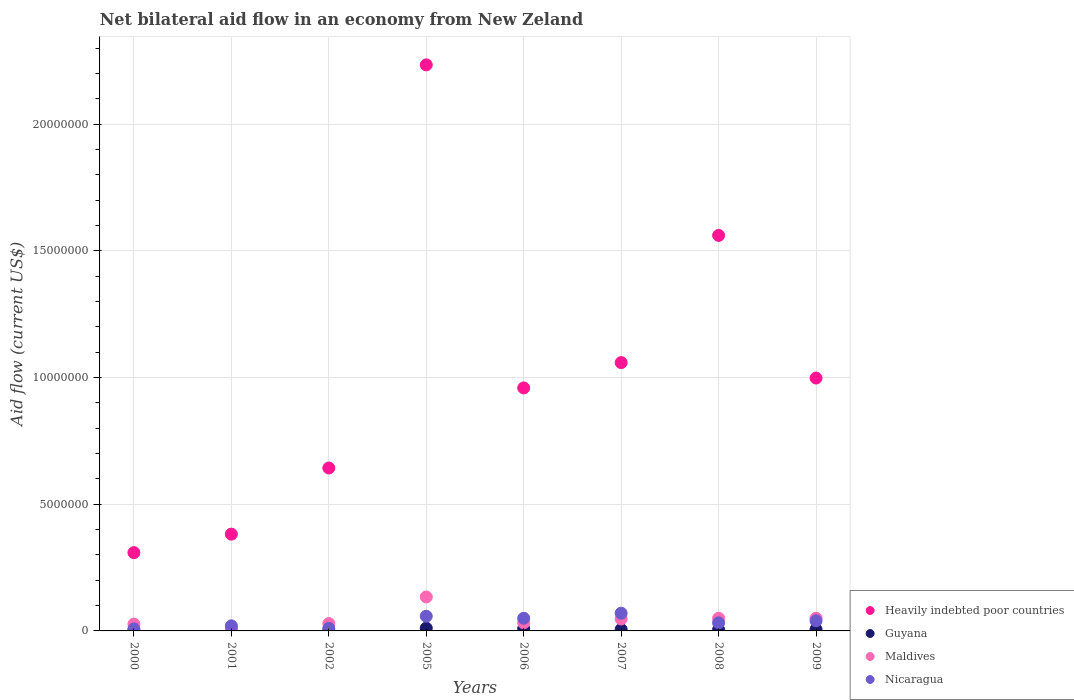Is the number of dotlines equal to the number of legend labels?
Your response must be concise. Yes. What is the net bilateral aid flow in Heavily indebted poor countries in 2009?
Offer a very short reply. 9.98e+06. Across all years, what is the maximum net bilateral aid flow in Guyana?
Give a very brief answer. 1.10e+05. Across all years, what is the minimum net bilateral aid flow in Maldives?
Your answer should be very brief. 1.20e+05. What is the total net bilateral aid flow in Nicaragua in the graph?
Your answer should be very brief. 2.88e+06. What is the difference between the net bilateral aid flow in Heavily indebted poor countries in 2001 and that in 2009?
Provide a succinct answer. -6.16e+06. What is the difference between the net bilateral aid flow in Guyana in 2006 and the net bilateral aid flow in Maldives in 2009?
Give a very brief answer. -4.10e+05. What is the average net bilateral aid flow in Heavily indebted poor countries per year?
Offer a terse response. 1.02e+07. In the year 2000, what is the difference between the net bilateral aid flow in Guyana and net bilateral aid flow in Maldives?
Offer a very short reply. -2.60e+05. In how many years, is the net bilateral aid flow in Guyana greater than 18000000 US$?
Offer a very short reply. 0. Is the difference between the net bilateral aid flow in Guyana in 2002 and 2005 greater than the difference between the net bilateral aid flow in Maldives in 2002 and 2005?
Ensure brevity in your answer.  Yes. What is the difference between the highest and the second highest net bilateral aid flow in Nicaragua?
Offer a very short reply. 1.20e+05. What is the difference between the highest and the lowest net bilateral aid flow in Maldives?
Offer a terse response. 1.22e+06. In how many years, is the net bilateral aid flow in Maldives greater than the average net bilateral aid flow in Maldives taken over all years?
Provide a short and direct response. 3. Is it the case that in every year, the sum of the net bilateral aid flow in Nicaragua and net bilateral aid flow in Guyana  is greater than the net bilateral aid flow in Maldives?
Your answer should be compact. No. Is the net bilateral aid flow in Heavily indebted poor countries strictly greater than the net bilateral aid flow in Guyana over the years?
Your answer should be compact. Yes. Is the net bilateral aid flow in Heavily indebted poor countries strictly less than the net bilateral aid flow in Nicaragua over the years?
Offer a terse response. No. How many dotlines are there?
Your answer should be very brief. 4. Are the values on the major ticks of Y-axis written in scientific E-notation?
Offer a terse response. No. Does the graph contain any zero values?
Offer a very short reply. No. Does the graph contain grids?
Keep it short and to the point. Yes. What is the title of the graph?
Provide a succinct answer. Net bilateral aid flow in an economy from New Zeland. What is the label or title of the X-axis?
Give a very brief answer. Years. What is the label or title of the Y-axis?
Provide a succinct answer. Aid flow (current US$). What is the Aid flow (current US$) in Heavily indebted poor countries in 2000?
Your response must be concise. 3.09e+06. What is the Aid flow (current US$) of Guyana in 2000?
Give a very brief answer. 10000. What is the Aid flow (current US$) of Heavily indebted poor countries in 2001?
Offer a very short reply. 3.82e+06. What is the Aid flow (current US$) of Guyana in 2001?
Ensure brevity in your answer.  10000. What is the Aid flow (current US$) of Maldives in 2001?
Your response must be concise. 1.20e+05. What is the Aid flow (current US$) of Heavily indebted poor countries in 2002?
Keep it short and to the point. 6.43e+06. What is the Aid flow (current US$) of Guyana in 2002?
Give a very brief answer. 10000. What is the Aid flow (current US$) of Maldives in 2002?
Your answer should be compact. 2.90e+05. What is the Aid flow (current US$) in Heavily indebted poor countries in 2005?
Provide a short and direct response. 2.23e+07. What is the Aid flow (current US$) of Maldives in 2005?
Provide a short and direct response. 1.34e+06. What is the Aid flow (current US$) of Nicaragua in 2005?
Give a very brief answer. 5.80e+05. What is the Aid flow (current US$) in Heavily indebted poor countries in 2006?
Ensure brevity in your answer.  9.59e+06. What is the Aid flow (current US$) of Maldives in 2006?
Provide a short and direct response. 3.20e+05. What is the Aid flow (current US$) in Heavily indebted poor countries in 2007?
Provide a short and direct response. 1.06e+07. What is the Aid flow (current US$) of Guyana in 2007?
Make the answer very short. 6.00e+04. What is the Aid flow (current US$) of Heavily indebted poor countries in 2008?
Your answer should be compact. 1.56e+07. What is the Aid flow (current US$) of Nicaragua in 2008?
Offer a very short reply. 3.20e+05. What is the Aid flow (current US$) in Heavily indebted poor countries in 2009?
Keep it short and to the point. 9.98e+06. What is the Aid flow (current US$) of Guyana in 2009?
Your response must be concise. 6.00e+04. What is the Aid flow (current US$) of Maldives in 2009?
Give a very brief answer. 5.00e+05. What is the Aid flow (current US$) in Nicaragua in 2009?
Keep it short and to the point. 4.00e+05. Across all years, what is the maximum Aid flow (current US$) in Heavily indebted poor countries?
Offer a terse response. 2.23e+07. Across all years, what is the maximum Aid flow (current US$) of Guyana?
Provide a succinct answer. 1.10e+05. Across all years, what is the maximum Aid flow (current US$) of Maldives?
Offer a terse response. 1.34e+06. Across all years, what is the minimum Aid flow (current US$) of Heavily indebted poor countries?
Offer a terse response. 3.09e+06. Across all years, what is the minimum Aid flow (current US$) in Nicaragua?
Your answer should be very brief. 8.00e+04. What is the total Aid flow (current US$) of Heavily indebted poor countries in the graph?
Your response must be concise. 8.14e+07. What is the total Aid flow (current US$) in Guyana in the graph?
Offer a very short reply. 4.00e+05. What is the total Aid flow (current US$) in Maldives in the graph?
Your response must be concise. 3.81e+06. What is the total Aid flow (current US$) of Nicaragua in the graph?
Make the answer very short. 2.88e+06. What is the difference between the Aid flow (current US$) of Heavily indebted poor countries in 2000 and that in 2001?
Provide a short and direct response. -7.30e+05. What is the difference between the Aid flow (current US$) in Guyana in 2000 and that in 2001?
Ensure brevity in your answer.  0. What is the difference between the Aid flow (current US$) in Maldives in 2000 and that in 2001?
Ensure brevity in your answer.  1.50e+05. What is the difference between the Aid flow (current US$) of Nicaragua in 2000 and that in 2001?
Provide a succinct answer. -1.20e+05. What is the difference between the Aid flow (current US$) in Heavily indebted poor countries in 2000 and that in 2002?
Ensure brevity in your answer.  -3.34e+06. What is the difference between the Aid flow (current US$) of Nicaragua in 2000 and that in 2002?
Provide a short and direct response. -2.00e+04. What is the difference between the Aid flow (current US$) in Heavily indebted poor countries in 2000 and that in 2005?
Keep it short and to the point. -1.92e+07. What is the difference between the Aid flow (current US$) in Maldives in 2000 and that in 2005?
Offer a terse response. -1.07e+06. What is the difference between the Aid flow (current US$) in Nicaragua in 2000 and that in 2005?
Make the answer very short. -5.00e+05. What is the difference between the Aid flow (current US$) of Heavily indebted poor countries in 2000 and that in 2006?
Provide a succinct answer. -6.50e+06. What is the difference between the Aid flow (current US$) of Maldives in 2000 and that in 2006?
Your answer should be compact. -5.00e+04. What is the difference between the Aid flow (current US$) in Nicaragua in 2000 and that in 2006?
Provide a short and direct response. -4.20e+05. What is the difference between the Aid flow (current US$) of Heavily indebted poor countries in 2000 and that in 2007?
Keep it short and to the point. -7.50e+06. What is the difference between the Aid flow (current US$) in Maldives in 2000 and that in 2007?
Keep it short and to the point. -2.00e+05. What is the difference between the Aid flow (current US$) of Nicaragua in 2000 and that in 2007?
Your answer should be very brief. -6.20e+05. What is the difference between the Aid flow (current US$) of Heavily indebted poor countries in 2000 and that in 2008?
Ensure brevity in your answer.  -1.25e+07. What is the difference between the Aid flow (current US$) of Guyana in 2000 and that in 2008?
Provide a succinct answer. -4.00e+04. What is the difference between the Aid flow (current US$) of Heavily indebted poor countries in 2000 and that in 2009?
Offer a terse response. -6.89e+06. What is the difference between the Aid flow (current US$) of Guyana in 2000 and that in 2009?
Offer a terse response. -5.00e+04. What is the difference between the Aid flow (current US$) of Maldives in 2000 and that in 2009?
Ensure brevity in your answer.  -2.30e+05. What is the difference between the Aid flow (current US$) of Nicaragua in 2000 and that in 2009?
Provide a short and direct response. -3.20e+05. What is the difference between the Aid flow (current US$) of Heavily indebted poor countries in 2001 and that in 2002?
Provide a short and direct response. -2.61e+06. What is the difference between the Aid flow (current US$) of Heavily indebted poor countries in 2001 and that in 2005?
Offer a terse response. -1.85e+07. What is the difference between the Aid flow (current US$) in Guyana in 2001 and that in 2005?
Ensure brevity in your answer.  -1.00e+05. What is the difference between the Aid flow (current US$) of Maldives in 2001 and that in 2005?
Your response must be concise. -1.22e+06. What is the difference between the Aid flow (current US$) of Nicaragua in 2001 and that in 2005?
Give a very brief answer. -3.80e+05. What is the difference between the Aid flow (current US$) of Heavily indebted poor countries in 2001 and that in 2006?
Your response must be concise. -5.77e+06. What is the difference between the Aid flow (current US$) in Nicaragua in 2001 and that in 2006?
Make the answer very short. -3.00e+05. What is the difference between the Aid flow (current US$) of Heavily indebted poor countries in 2001 and that in 2007?
Your response must be concise. -6.77e+06. What is the difference between the Aid flow (current US$) in Maldives in 2001 and that in 2007?
Offer a terse response. -3.50e+05. What is the difference between the Aid flow (current US$) of Nicaragua in 2001 and that in 2007?
Ensure brevity in your answer.  -5.00e+05. What is the difference between the Aid flow (current US$) of Heavily indebted poor countries in 2001 and that in 2008?
Offer a very short reply. -1.18e+07. What is the difference between the Aid flow (current US$) in Maldives in 2001 and that in 2008?
Offer a terse response. -3.80e+05. What is the difference between the Aid flow (current US$) in Heavily indebted poor countries in 2001 and that in 2009?
Give a very brief answer. -6.16e+06. What is the difference between the Aid flow (current US$) of Guyana in 2001 and that in 2009?
Make the answer very short. -5.00e+04. What is the difference between the Aid flow (current US$) of Maldives in 2001 and that in 2009?
Ensure brevity in your answer.  -3.80e+05. What is the difference between the Aid flow (current US$) in Heavily indebted poor countries in 2002 and that in 2005?
Provide a succinct answer. -1.59e+07. What is the difference between the Aid flow (current US$) in Maldives in 2002 and that in 2005?
Give a very brief answer. -1.05e+06. What is the difference between the Aid flow (current US$) in Nicaragua in 2002 and that in 2005?
Your answer should be compact. -4.80e+05. What is the difference between the Aid flow (current US$) of Heavily indebted poor countries in 2002 and that in 2006?
Your answer should be very brief. -3.16e+06. What is the difference between the Aid flow (current US$) in Maldives in 2002 and that in 2006?
Make the answer very short. -3.00e+04. What is the difference between the Aid flow (current US$) of Nicaragua in 2002 and that in 2006?
Provide a succinct answer. -4.00e+05. What is the difference between the Aid flow (current US$) of Heavily indebted poor countries in 2002 and that in 2007?
Your answer should be very brief. -4.16e+06. What is the difference between the Aid flow (current US$) in Guyana in 2002 and that in 2007?
Provide a succinct answer. -5.00e+04. What is the difference between the Aid flow (current US$) of Nicaragua in 2002 and that in 2007?
Provide a short and direct response. -6.00e+05. What is the difference between the Aid flow (current US$) of Heavily indebted poor countries in 2002 and that in 2008?
Ensure brevity in your answer.  -9.18e+06. What is the difference between the Aid flow (current US$) in Maldives in 2002 and that in 2008?
Make the answer very short. -2.10e+05. What is the difference between the Aid flow (current US$) of Nicaragua in 2002 and that in 2008?
Offer a terse response. -2.20e+05. What is the difference between the Aid flow (current US$) of Heavily indebted poor countries in 2002 and that in 2009?
Offer a terse response. -3.55e+06. What is the difference between the Aid flow (current US$) in Guyana in 2002 and that in 2009?
Your answer should be compact. -5.00e+04. What is the difference between the Aid flow (current US$) in Maldives in 2002 and that in 2009?
Offer a very short reply. -2.10e+05. What is the difference between the Aid flow (current US$) of Nicaragua in 2002 and that in 2009?
Offer a terse response. -3.00e+05. What is the difference between the Aid flow (current US$) in Heavily indebted poor countries in 2005 and that in 2006?
Ensure brevity in your answer.  1.28e+07. What is the difference between the Aid flow (current US$) of Maldives in 2005 and that in 2006?
Your answer should be compact. 1.02e+06. What is the difference between the Aid flow (current US$) of Nicaragua in 2005 and that in 2006?
Provide a short and direct response. 8.00e+04. What is the difference between the Aid flow (current US$) in Heavily indebted poor countries in 2005 and that in 2007?
Ensure brevity in your answer.  1.18e+07. What is the difference between the Aid flow (current US$) of Maldives in 2005 and that in 2007?
Keep it short and to the point. 8.70e+05. What is the difference between the Aid flow (current US$) in Nicaragua in 2005 and that in 2007?
Make the answer very short. -1.20e+05. What is the difference between the Aid flow (current US$) of Heavily indebted poor countries in 2005 and that in 2008?
Your answer should be compact. 6.73e+06. What is the difference between the Aid flow (current US$) in Guyana in 2005 and that in 2008?
Offer a very short reply. 6.00e+04. What is the difference between the Aid flow (current US$) of Maldives in 2005 and that in 2008?
Your response must be concise. 8.40e+05. What is the difference between the Aid flow (current US$) in Heavily indebted poor countries in 2005 and that in 2009?
Provide a short and direct response. 1.24e+07. What is the difference between the Aid flow (current US$) in Maldives in 2005 and that in 2009?
Make the answer very short. 8.40e+05. What is the difference between the Aid flow (current US$) of Nicaragua in 2005 and that in 2009?
Offer a very short reply. 1.80e+05. What is the difference between the Aid flow (current US$) of Maldives in 2006 and that in 2007?
Your response must be concise. -1.50e+05. What is the difference between the Aid flow (current US$) in Nicaragua in 2006 and that in 2007?
Your answer should be compact. -2.00e+05. What is the difference between the Aid flow (current US$) in Heavily indebted poor countries in 2006 and that in 2008?
Your answer should be compact. -6.02e+06. What is the difference between the Aid flow (current US$) in Guyana in 2006 and that in 2008?
Your response must be concise. 4.00e+04. What is the difference between the Aid flow (current US$) of Heavily indebted poor countries in 2006 and that in 2009?
Provide a succinct answer. -3.90e+05. What is the difference between the Aid flow (current US$) in Guyana in 2006 and that in 2009?
Ensure brevity in your answer.  3.00e+04. What is the difference between the Aid flow (current US$) of Heavily indebted poor countries in 2007 and that in 2008?
Keep it short and to the point. -5.02e+06. What is the difference between the Aid flow (current US$) in Maldives in 2007 and that in 2008?
Your response must be concise. -3.00e+04. What is the difference between the Aid flow (current US$) in Nicaragua in 2007 and that in 2008?
Offer a very short reply. 3.80e+05. What is the difference between the Aid flow (current US$) in Heavily indebted poor countries in 2007 and that in 2009?
Your answer should be compact. 6.10e+05. What is the difference between the Aid flow (current US$) in Guyana in 2007 and that in 2009?
Ensure brevity in your answer.  0. What is the difference between the Aid flow (current US$) of Maldives in 2007 and that in 2009?
Your response must be concise. -3.00e+04. What is the difference between the Aid flow (current US$) in Heavily indebted poor countries in 2008 and that in 2009?
Make the answer very short. 5.63e+06. What is the difference between the Aid flow (current US$) in Guyana in 2008 and that in 2009?
Provide a short and direct response. -10000. What is the difference between the Aid flow (current US$) in Maldives in 2008 and that in 2009?
Offer a terse response. 0. What is the difference between the Aid flow (current US$) in Heavily indebted poor countries in 2000 and the Aid flow (current US$) in Guyana in 2001?
Make the answer very short. 3.08e+06. What is the difference between the Aid flow (current US$) in Heavily indebted poor countries in 2000 and the Aid flow (current US$) in Maldives in 2001?
Offer a terse response. 2.97e+06. What is the difference between the Aid flow (current US$) of Heavily indebted poor countries in 2000 and the Aid flow (current US$) of Nicaragua in 2001?
Provide a short and direct response. 2.89e+06. What is the difference between the Aid flow (current US$) of Guyana in 2000 and the Aid flow (current US$) of Maldives in 2001?
Your answer should be compact. -1.10e+05. What is the difference between the Aid flow (current US$) in Maldives in 2000 and the Aid flow (current US$) in Nicaragua in 2001?
Your answer should be compact. 7.00e+04. What is the difference between the Aid flow (current US$) of Heavily indebted poor countries in 2000 and the Aid flow (current US$) of Guyana in 2002?
Offer a terse response. 3.08e+06. What is the difference between the Aid flow (current US$) of Heavily indebted poor countries in 2000 and the Aid flow (current US$) of Maldives in 2002?
Your response must be concise. 2.80e+06. What is the difference between the Aid flow (current US$) in Heavily indebted poor countries in 2000 and the Aid flow (current US$) in Nicaragua in 2002?
Keep it short and to the point. 2.99e+06. What is the difference between the Aid flow (current US$) in Guyana in 2000 and the Aid flow (current US$) in Maldives in 2002?
Your answer should be very brief. -2.80e+05. What is the difference between the Aid flow (current US$) in Guyana in 2000 and the Aid flow (current US$) in Nicaragua in 2002?
Your answer should be compact. -9.00e+04. What is the difference between the Aid flow (current US$) of Maldives in 2000 and the Aid flow (current US$) of Nicaragua in 2002?
Ensure brevity in your answer.  1.70e+05. What is the difference between the Aid flow (current US$) of Heavily indebted poor countries in 2000 and the Aid flow (current US$) of Guyana in 2005?
Provide a short and direct response. 2.98e+06. What is the difference between the Aid flow (current US$) in Heavily indebted poor countries in 2000 and the Aid flow (current US$) in Maldives in 2005?
Your answer should be compact. 1.75e+06. What is the difference between the Aid flow (current US$) in Heavily indebted poor countries in 2000 and the Aid flow (current US$) in Nicaragua in 2005?
Provide a short and direct response. 2.51e+06. What is the difference between the Aid flow (current US$) of Guyana in 2000 and the Aid flow (current US$) of Maldives in 2005?
Ensure brevity in your answer.  -1.33e+06. What is the difference between the Aid flow (current US$) of Guyana in 2000 and the Aid flow (current US$) of Nicaragua in 2005?
Make the answer very short. -5.70e+05. What is the difference between the Aid flow (current US$) in Maldives in 2000 and the Aid flow (current US$) in Nicaragua in 2005?
Give a very brief answer. -3.10e+05. What is the difference between the Aid flow (current US$) of Heavily indebted poor countries in 2000 and the Aid flow (current US$) of Guyana in 2006?
Make the answer very short. 3.00e+06. What is the difference between the Aid flow (current US$) of Heavily indebted poor countries in 2000 and the Aid flow (current US$) of Maldives in 2006?
Provide a succinct answer. 2.77e+06. What is the difference between the Aid flow (current US$) in Heavily indebted poor countries in 2000 and the Aid flow (current US$) in Nicaragua in 2006?
Ensure brevity in your answer.  2.59e+06. What is the difference between the Aid flow (current US$) in Guyana in 2000 and the Aid flow (current US$) in Maldives in 2006?
Your answer should be very brief. -3.10e+05. What is the difference between the Aid flow (current US$) of Guyana in 2000 and the Aid flow (current US$) of Nicaragua in 2006?
Ensure brevity in your answer.  -4.90e+05. What is the difference between the Aid flow (current US$) of Heavily indebted poor countries in 2000 and the Aid flow (current US$) of Guyana in 2007?
Your answer should be compact. 3.03e+06. What is the difference between the Aid flow (current US$) in Heavily indebted poor countries in 2000 and the Aid flow (current US$) in Maldives in 2007?
Give a very brief answer. 2.62e+06. What is the difference between the Aid flow (current US$) of Heavily indebted poor countries in 2000 and the Aid flow (current US$) of Nicaragua in 2007?
Provide a succinct answer. 2.39e+06. What is the difference between the Aid flow (current US$) of Guyana in 2000 and the Aid flow (current US$) of Maldives in 2007?
Your answer should be compact. -4.60e+05. What is the difference between the Aid flow (current US$) in Guyana in 2000 and the Aid flow (current US$) in Nicaragua in 2007?
Keep it short and to the point. -6.90e+05. What is the difference between the Aid flow (current US$) in Maldives in 2000 and the Aid flow (current US$) in Nicaragua in 2007?
Provide a short and direct response. -4.30e+05. What is the difference between the Aid flow (current US$) in Heavily indebted poor countries in 2000 and the Aid flow (current US$) in Guyana in 2008?
Provide a short and direct response. 3.04e+06. What is the difference between the Aid flow (current US$) of Heavily indebted poor countries in 2000 and the Aid flow (current US$) of Maldives in 2008?
Ensure brevity in your answer.  2.59e+06. What is the difference between the Aid flow (current US$) in Heavily indebted poor countries in 2000 and the Aid flow (current US$) in Nicaragua in 2008?
Provide a succinct answer. 2.77e+06. What is the difference between the Aid flow (current US$) in Guyana in 2000 and the Aid flow (current US$) in Maldives in 2008?
Ensure brevity in your answer.  -4.90e+05. What is the difference between the Aid flow (current US$) of Guyana in 2000 and the Aid flow (current US$) of Nicaragua in 2008?
Your response must be concise. -3.10e+05. What is the difference between the Aid flow (current US$) in Maldives in 2000 and the Aid flow (current US$) in Nicaragua in 2008?
Your answer should be very brief. -5.00e+04. What is the difference between the Aid flow (current US$) of Heavily indebted poor countries in 2000 and the Aid flow (current US$) of Guyana in 2009?
Ensure brevity in your answer.  3.03e+06. What is the difference between the Aid flow (current US$) in Heavily indebted poor countries in 2000 and the Aid flow (current US$) in Maldives in 2009?
Give a very brief answer. 2.59e+06. What is the difference between the Aid flow (current US$) in Heavily indebted poor countries in 2000 and the Aid flow (current US$) in Nicaragua in 2009?
Make the answer very short. 2.69e+06. What is the difference between the Aid flow (current US$) in Guyana in 2000 and the Aid flow (current US$) in Maldives in 2009?
Your response must be concise. -4.90e+05. What is the difference between the Aid flow (current US$) in Guyana in 2000 and the Aid flow (current US$) in Nicaragua in 2009?
Give a very brief answer. -3.90e+05. What is the difference between the Aid flow (current US$) in Heavily indebted poor countries in 2001 and the Aid flow (current US$) in Guyana in 2002?
Offer a terse response. 3.81e+06. What is the difference between the Aid flow (current US$) in Heavily indebted poor countries in 2001 and the Aid flow (current US$) in Maldives in 2002?
Give a very brief answer. 3.53e+06. What is the difference between the Aid flow (current US$) in Heavily indebted poor countries in 2001 and the Aid flow (current US$) in Nicaragua in 2002?
Provide a succinct answer. 3.72e+06. What is the difference between the Aid flow (current US$) in Guyana in 2001 and the Aid flow (current US$) in Maldives in 2002?
Offer a terse response. -2.80e+05. What is the difference between the Aid flow (current US$) of Guyana in 2001 and the Aid flow (current US$) of Nicaragua in 2002?
Provide a succinct answer. -9.00e+04. What is the difference between the Aid flow (current US$) in Heavily indebted poor countries in 2001 and the Aid flow (current US$) in Guyana in 2005?
Provide a succinct answer. 3.71e+06. What is the difference between the Aid flow (current US$) in Heavily indebted poor countries in 2001 and the Aid flow (current US$) in Maldives in 2005?
Make the answer very short. 2.48e+06. What is the difference between the Aid flow (current US$) in Heavily indebted poor countries in 2001 and the Aid flow (current US$) in Nicaragua in 2005?
Make the answer very short. 3.24e+06. What is the difference between the Aid flow (current US$) of Guyana in 2001 and the Aid flow (current US$) of Maldives in 2005?
Your answer should be very brief. -1.33e+06. What is the difference between the Aid flow (current US$) of Guyana in 2001 and the Aid flow (current US$) of Nicaragua in 2005?
Keep it short and to the point. -5.70e+05. What is the difference between the Aid flow (current US$) of Maldives in 2001 and the Aid flow (current US$) of Nicaragua in 2005?
Give a very brief answer. -4.60e+05. What is the difference between the Aid flow (current US$) of Heavily indebted poor countries in 2001 and the Aid flow (current US$) of Guyana in 2006?
Offer a terse response. 3.73e+06. What is the difference between the Aid flow (current US$) in Heavily indebted poor countries in 2001 and the Aid flow (current US$) in Maldives in 2006?
Ensure brevity in your answer.  3.50e+06. What is the difference between the Aid flow (current US$) of Heavily indebted poor countries in 2001 and the Aid flow (current US$) of Nicaragua in 2006?
Offer a very short reply. 3.32e+06. What is the difference between the Aid flow (current US$) in Guyana in 2001 and the Aid flow (current US$) in Maldives in 2006?
Your answer should be compact. -3.10e+05. What is the difference between the Aid flow (current US$) of Guyana in 2001 and the Aid flow (current US$) of Nicaragua in 2006?
Keep it short and to the point. -4.90e+05. What is the difference between the Aid flow (current US$) of Maldives in 2001 and the Aid flow (current US$) of Nicaragua in 2006?
Ensure brevity in your answer.  -3.80e+05. What is the difference between the Aid flow (current US$) of Heavily indebted poor countries in 2001 and the Aid flow (current US$) of Guyana in 2007?
Provide a succinct answer. 3.76e+06. What is the difference between the Aid flow (current US$) in Heavily indebted poor countries in 2001 and the Aid flow (current US$) in Maldives in 2007?
Provide a short and direct response. 3.35e+06. What is the difference between the Aid flow (current US$) in Heavily indebted poor countries in 2001 and the Aid flow (current US$) in Nicaragua in 2007?
Your answer should be very brief. 3.12e+06. What is the difference between the Aid flow (current US$) in Guyana in 2001 and the Aid flow (current US$) in Maldives in 2007?
Ensure brevity in your answer.  -4.60e+05. What is the difference between the Aid flow (current US$) in Guyana in 2001 and the Aid flow (current US$) in Nicaragua in 2007?
Give a very brief answer. -6.90e+05. What is the difference between the Aid flow (current US$) of Maldives in 2001 and the Aid flow (current US$) of Nicaragua in 2007?
Offer a very short reply. -5.80e+05. What is the difference between the Aid flow (current US$) in Heavily indebted poor countries in 2001 and the Aid flow (current US$) in Guyana in 2008?
Offer a terse response. 3.77e+06. What is the difference between the Aid flow (current US$) of Heavily indebted poor countries in 2001 and the Aid flow (current US$) of Maldives in 2008?
Offer a terse response. 3.32e+06. What is the difference between the Aid flow (current US$) in Heavily indebted poor countries in 2001 and the Aid flow (current US$) in Nicaragua in 2008?
Offer a very short reply. 3.50e+06. What is the difference between the Aid flow (current US$) of Guyana in 2001 and the Aid flow (current US$) of Maldives in 2008?
Your answer should be compact. -4.90e+05. What is the difference between the Aid flow (current US$) of Guyana in 2001 and the Aid flow (current US$) of Nicaragua in 2008?
Offer a terse response. -3.10e+05. What is the difference between the Aid flow (current US$) of Heavily indebted poor countries in 2001 and the Aid flow (current US$) of Guyana in 2009?
Your answer should be compact. 3.76e+06. What is the difference between the Aid flow (current US$) of Heavily indebted poor countries in 2001 and the Aid flow (current US$) of Maldives in 2009?
Your response must be concise. 3.32e+06. What is the difference between the Aid flow (current US$) in Heavily indebted poor countries in 2001 and the Aid flow (current US$) in Nicaragua in 2009?
Make the answer very short. 3.42e+06. What is the difference between the Aid flow (current US$) in Guyana in 2001 and the Aid flow (current US$) in Maldives in 2009?
Provide a short and direct response. -4.90e+05. What is the difference between the Aid flow (current US$) in Guyana in 2001 and the Aid flow (current US$) in Nicaragua in 2009?
Ensure brevity in your answer.  -3.90e+05. What is the difference between the Aid flow (current US$) of Maldives in 2001 and the Aid flow (current US$) of Nicaragua in 2009?
Your answer should be compact. -2.80e+05. What is the difference between the Aid flow (current US$) in Heavily indebted poor countries in 2002 and the Aid flow (current US$) in Guyana in 2005?
Your response must be concise. 6.32e+06. What is the difference between the Aid flow (current US$) in Heavily indebted poor countries in 2002 and the Aid flow (current US$) in Maldives in 2005?
Make the answer very short. 5.09e+06. What is the difference between the Aid flow (current US$) of Heavily indebted poor countries in 2002 and the Aid flow (current US$) of Nicaragua in 2005?
Make the answer very short. 5.85e+06. What is the difference between the Aid flow (current US$) in Guyana in 2002 and the Aid flow (current US$) in Maldives in 2005?
Ensure brevity in your answer.  -1.33e+06. What is the difference between the Aid flow (current US$) of Guyana in 2002 and the Aid flow (current US$) of Nicaragua in 2005?
Offer a very short reply. -5.70e+05. What is the difference between the Aid flow (current US$) in Heavily indebted poor countries in 2002 and the Aid flow (current US$) in Guyana in 2006?
Keep it short and to the point. 6.34e+06. What is the difference between the Aid flow (current US$) in Heavily indebted poor countries in 2002 and the Aid flow (current US$) in Maldives in 2006?
Your answer should be compact. 6.11e+06. What is the difference between the Aid flow (current US$) of Heavily indebted poor countries in 2002 and the Aid flow (current US$) of Nicaragua in 2006?
Your answer should be very brief. 5.93e+06. What is the difference between the Aid flow (current US$) of Guyana in 2002 and the Aid flow (current US$) of Maldives in 2006?
Ensure brevity in your answer.  -3.10e+05. What is the difference between the Aid flow (current US$) in Guyana in 2002 and the Aid flow (current US$) in Nicaragua in 2006?
Give a very brief answer. -4.90e+05. What is the difference between the Aid flow (current US$) in Heavily indebted poor countries in 2002 and the Aid flow (current US$) in Guyana in 2007?
Ensure brevity in your answer.  6.37e+06. What is the difference between the Aid flow (current US$) in Heavily indebted poor countries in 2002 and the Aid flow (current US$) in Maldives in 2007?
Make the answer very short. 5.96e+06. What is the difference between the Aid flow (current US$) in Heavily indebted poor countries in 2002 and the Aid flow (current US$) in Nicaragua in 2007?
Your answer should be compact. 5.73e+06. What is the difference between the Aid flow (current US$) in Guyana in 2002 and the Aid flow (current US$) in Maldives in 2007?
Provide a succinct answer. -4.60e+05. What is the difference between the Aid flow (current US$) of Guyana in 2002 and the Aid flow (current US$) of Nicaragua in 2007?
Keep it short and to the point. -6.90e+05. What is the difference between the Aid flow (current US$) in Maldives in 2002 and the Aid flow (current US$) in Nicaragua in 2007?
Provide a short and direct response. -4.10e+05. What is the difference between the Aid flow (current US$) in Heavily indebted poor countries in 2002 and the Aid flow (current US$) in Guyana in 2008?
Provide a succinct answer. 6.38e+06. What is the difference between the Aid flow (current US$) in Heavily indebted poor countries in 2002 and the Aid flow (current US$) in Maldives in 2008?
Make the answer very short. 5.93e+06. What is the difference between the Aid flow (current US$) of Heavily indebted poor countries in 2002 and the Aid flow (current US$) of Nicaragua in 2008?
Provide a short and direct response. 6.11e+06. What is the difference between the Aid flow (current US$) in Guyana in 2002 and the Aid flow (current US$) in Maldives in 2008?
Offer a very short reply. -4.90e+05. What is the difference between the Aid flow (current US$) of Guyana in 2002 and the Aid flow (current US$) of Nicaragua in 2008?
Offer a terse response. -3.10e+05. What is the difference between the Aid flow (current US$) in Heavily indebted poor countries in 2002 and the Aid flow (current US$) in Guyana in 2009?
Offer a terse response. 6.37e+06. What is the difference between the Aid flow (current US$) in Heavily indebted poor countries in 2002 and the Aid flow (current US$) in Maldives in 2009?
Make the answer very short. 5.93e+06. What is the difference between the Aid flow (current US$) of Heavily indebted poor countries in 2002 and the Aid flow (current US$) of Nicaragua in 2009?
Your answer should be compact. 6.03e+06. What is the difference between the Aid flow (current US$) of Guyana in 2002 and the Aid flow (current US$) of Maldives in 2009?
Make the answer very short. -4.90e+05. What is the difference between the Aid flow (current US$) of Guyana in 2002 and the Aid flow (current US$) of Nicaragua in 2009?
Keep it short and to the point. -3.90e+05. What is the difference between the Aid flow (current US$) of Heavily indebted poor countries in 2005 and the Aid flow (current US$) of Guyana in 2006?
Give a very brief answer. 2.22e+07. What is the difference between the Aid flow (current US$) of Heavily indebted poor countries in 2005 and the Aid flow (current US$) of Maldives in 2006?
Make the answer very short. 2.20e+07. What is the difference between the Aid flow (current US$) in Heavily indebted poor countries in 2005 and the Aid flow (current US$) in Nicaragua in 2006?
Give a very brief answer. 2.18e+07. What is the difference between the Aid flow (current US$) of Guyana in 2005 and the Aid flow (current US$) of Nicaragua in 2006?
Offer a very short reply. -3.90e+05. What is the difference between the Aid flow (current US$) in Maldives in 2005 and the Aid flow (current US$) in Nicaragua in 2006?
Give a very brief answer. 8.40e+05. What is the difference between the Aid flow (current US$) of Heavily indebted poor countries in 2005 and the Aid flow (current US$) of Guyana in 2007?
Offer a very short reply. 2.23e+07. What is the difference between the Aid flow (current US$) of Heavily indebted poor countries in 2005 and the Aid flow (current US$) of Maldives in 2007?
Make the answer very short. 2.19e+07. What is the difference between the Aid flow (current US$) in Heavily indebted poor countries in 2005 and the Aid flow (current US$) in Nicaragua in 2007?
Your response must be concise. 2.16e+07. What is the difference between the Aid flow (current US$) of Guyana in 2005 and the Aid flow (current US$) of Maldives in 2007?
Make the answer very short. -3.60e+05. What is the difference between the Aid flow (current US$) of Guyana in 2005 and the Aid flow (current US$) of Nicaragua in 2007?
Your response must be concise. -5.90e+05. What is the difference between the Aid flow (current US$) in Maldives in 2005 and the Aid flow (current US$) in Nicaragua in 2007?
Ensure brevity in your answer.  6.40e+05. What is the difference between the Aid flow (current US$) in Heavily indebted poor countries in 2005 and the Aid flow (current US$) in Guyana in 2008?
Ensure brevity in your answer.  2.23e+07. What is the difference between the Aid flow (current US$) of Heavily indebted poor countries in 2005 and the Aid flow (current US$) of Maldives in 2008?
Your answer should be compact. 2.18e+07. What is the difference between the Aid flow (current US$) of Heavily indebted poor countries in 2005 and the Aid flow (current US$) of Nicaragua in 2008?
Give a very brief answer. 2.20e+07. What is the difference between the Aid flow (current US$) of Guyana in 2005 and the Aid flow (current US$) of Maldives in 2008?
Provide a succinct answer. -3.90e+05. What is the difference between the Aid flow (current US$) in Maldives in 2005 and the Aid flow (current US$) in Nicaragua in 2008?
Make the answer very short. 1.02e+06. What is the difference between the Aid flow (current US$) of Heavily indebted poor countries in 2005 and the Aid flow (current US$) of Guyana in 2009?
Offer a terse response. 2.23e+07. What is the difference between the Aid flow (current US$) in Heavily indebted poor countries in 2005 and the Aid flow (current US$) in Maldives in 2009?
Your answer should be compact. 2.18e+07. What is the difference between the Aid flow (current US$) of Heavily indebted poor countries in 2005 and the Aid flow (current US$) of Nicaragua in 2009?
Give a very brief answer. 2.19e+07. What is the difference between the Aid flow (current US$) of Guyana in 2005 and the Aid flow (current US$) of Maldives in 2009?
Provide a short and direct response. -3.90e+05. What is the difference between the Aid flow (current US$) in Maldives in 2005 and the Aid flow (current US$) in Nicaragua in 2009?
Provide a short and direct response. 9.40e+05. What is the difference between the Aid flow (current US$) in Heavily indebted poor countries in 2006 and the Aid flow (current US$) in Guyana in 2007?
Your answer should be compact. 9.53e+06. What is the difference between the Aid flow (current US$) of Heavily indebted poor countries in 2006 and the Aid flow (current US$) of Maldives in 2007?
Provide a succinct answer. 9.12e+06. What is the difference between the Aid flow (current US$) of Heavily indebted poor countries in 2006 and the Aid flow (current US$) of Nicaragua in 2007?
Keep it short and to the point. 8.89e+06. What is the difference between the Aid flow (current US$) in Guyana in 2006 and the Aid flow (current US$) in Maldives in 2007?
Your response must be concise. -3.80e+05. What is the difference between the Aid flow (current US$) in Guyana in 2006 and the Aid flow (current US$) in Nicaragua in 2007?
Offer a terse response. -6.10e+05. What is the difference between the Aid flow (current US$) of Maldives in 2006 and the Aid flow (current US$) of Nicaragua in 2007?
Make the answer very short. -3.80e+05. What is the difference between the Aid flow (current US$) of Heavily indebted poor countries in 2006 and the Aid flow (current US$) of Guyana in 2008?
Your answer should be very brief. 9.54e+06. What is the difference between the Aid flow (current US$) of Heavily indebted poor countries in 2006 and the Aid flow (current US$) of Maldives in 2008?
Ensure brevity in your answer.  9.09e+06. What is the difference between the Aid flow (current US$) of Heavily indebted poor countries in 2006 and the Aid flow (current US$) of Nicaragua in 2008?
Offer a very short reply. 9.27e+06. What is the difference between the Aid flow (current US$) in Guyana in 2006 and the Aid flow (current US$) in Maldives in 2008?
Give a very brief answer. -4.10e+05. What is the difference between the Aid flow (current US$) in Heavily indebted poor countries in 2006 and the Aid flow (current US$) in Guyana in 2009?
Ensure brevity in your answer.  9.53e+06. What is the difference between the Aid flow (current US$) of Heavily indebted poor countries in 2006 and the Aid flow (current US$) of Maldives in 2009?
Your answer should be very brief. 9.09e+06. What is the difference between the Aid flow (current US$) of Heavily indebted poor countries in 2006 and the Aid flow (current US$) of Nicaragua in 2009?
Ensure brevity in your answer.  9.19e+06. What is the difference between the Aid flow (current US$) in Guyana in 2006 and the Aid flow (current US$) in Maldives in 2009?
Your answer should be very brief. -4.10e+05. What is the difference between the Aid flow (current US$) in Guyana in 2006 and the Aid flow (current US$) in Nicaragua in 2009?
Make the answer very short. -3.10e+05. What is the difference between the Aid flow (current US$) in Heavily indebted poor countries in 2007 and the Aid flow (current US$) in Guyana in 2008?
Offer a terse response. 1.05e+07. What is the difference between the Aid flow (current US$) of Heavily indebted poor countries in 2007 and the Aid flow (current US$) of Maldives in 2008?
Give a very brief answer. 1.01e+07. What is the difference between the Aid flow (current US$) of Heavily indebted poor countries in 2007 and the Aid flow (current US$) of Nicaragua in 2008?
Your response must be concise. 1.03e+07. What is the difference between the Aid flow (current US$) in Guyana in 2007 and the Aid flow (current US$) in Maldives in 2008?
Provide a succinct answer. -4.40e+05. What is the difference between the Aid flow (current US$) of Heavily indebted poor countries in 2007 and the Aid flow (current US$) of Guyana in 2009?
Make the answer very short. 1.05e+07. What is the difference between the Aid flow (current US$) of Heavily indebted poor countries in 2007 and the Aid flow (current US$) of Maldives in 2009?
Provide a short and direct response. 1.01e+07. What is the difference between the Aid flow (current US$) of Heavily indebted poor countries in 2007 and the Aid flow (current US$) of Nicaragua in 2009?
Offer a terse response. 1.02e+07. What is the difference between the Aid flow (current US$) of Guyana in 2007 and the Aid flow (current US$) of Maldives in 2009?
Your answer should be compact. -4.40e+05. What is the difference between the Aid flow (current US$) in Guyana in 2007 and the Aid flow (current US$) in Nicaragua in 2009?
Make the answer very short. -3.40e+05. What is the difference between the Aid flow (current US$) in Heavily indebted poor countries in 2008 and the Aid flow (current US$) in Guyana in 2009?
Offer a very short reply. 1.56e+07. What is the difference between the Aid flow (current US$) of Heavily indebted poor countries in 2008 and the Aid flow (current US$) of Maldives in 2009?
Provide a short and direct response. 1.51e+07. What is the difference between the Aid flow (current US$) of Heavily indebted poor countries in 2008 and the Aid flow (current US$) of Nicaragua in 2009?
Your answer should be very brief. 1.52e+07. What is the difference between the Aid flow (current US$) of Guyana in 2008 and the Aid flow (current US$) of Maldives in 2009?
Offer a terse response. -4.50e+05. What is the difference between the Aid flow (current US$) of Guyana in 2008 and the Aid flow (current US$) of Nicaragua in 2009?
Keep it short and to the point. -3.50e+05. What is the average Aid flow (current US$) in Heavily indebted poor countries per year?
Give a very brief answer. 1.02e+07. What is the average Aid flow (current US$) in Maldives per year?
Provide a short and direct response. 4.76e+05. What is the average Aid flow (current US$) in Nicaragua per year?
Give a very brief answer. 3.60e+05. In the year 2000, what is the difference between the Aid flow (current US$) of Heavily indebted poor countries and Aid flow (current US$) of Guyana?
Ensure brevity in your answer.  3.08e+06. In the year 2000, what is the difference between the Aid flow (current US$) of Heavily indebted poor countries and Aid flow (current US$) of Maldives?
Provide a short and direct response. 2.82e+06. In the year 2000, what is the difference between the Aid flow (current US$) of Heavily indebted poor countries and Aid flow (current US$) of Nicaragua?
Your answer should be very brief. 3.01e+06. In the year 2000, what is the difference between the Aid flow (current US$) in Guyana and Aid flow (current US$) in Maldives?
Give a very brief answer. -2.60e+05. In the year 2000, what is the difference between the Aid flow (current US$) in Maldives and Aid flow (current US$) in Nicaragua?
Provide a succinct answer. 1.90e+05. In the year 2001, what is the difference between the Aid flow (current US$) of Heavily indebted poor countries and Aid flow (current US$) of Guyana?
Offer a terse response. 3.81e+06. In the year 2001, what is the difference between the Aid flow (current US$) in Heavily indebted poor countries and Aid flow (current US$) in Maldives?
Offer a very short reply. 3.70e+06. In the year 2001, what is the difference between the Aid flow (current US$) in Heavily indebted poor countries and Aid flow (current US$) in Nicaragua?
Keep it short and to the point. 3.62e+06. In the year 2001, what is the difference between the Aid flow (current US$) of Guyana and Aid flow (current US$) of Maldives?
Your response must be concise. -1.10e+05. In the year 2001, what is the difference between the Aid flow (current US$) of Guyana and Aid flow (current US$) of Nicaragua?
Provide a succinct answer. -1.90e+05. In the year 2001, what is the difference between the Aid flow (current US$) of Maldives and Aid flow (current US$) of Nicaragua?
Provide a succinct answer. -8.00e+04. In the year 2002, what is the difference between the Aid flow (current US$) in Heavily indebted poor countries and Aid flow (current US$) in Guyana?
Your answer should be very brief. 6.42e+06. In the year 2002, what is the difference between the Aid flow (current US$) of Heavily indebted poor countries and Aid flow (current US$) of Maldives?
Your response must be concise. 6.14e+06. In the year 2002, what is the difference between the Aid flow (current US$) in Heavily indebted poor countries and Aid flow (current US$) in Nicaragua?
Offer a very short reply. 6.33e+06. In the year 2002, what is the difference between the Aid flow (current US$) in Guyana and Aid flow (current US$) in Maldives?
Keep it short and to the point. -2.80e+05. In the year 2002, what is the difference between the Aid flow (current US$) of Maldives and Aid flow (current US$) of Nicaragua?
Your response must be concise. 1.90e+05. In the year 2005, what is the difference between the Aid flow (current US$) of Heavily indebted poor countries and Aid flow (current US$) of Guyana?
Offer a very short reply. 2.22e+07. In the year 2005, what is the difference between the Aid flow (current US$) in Heavily indebted poor countries and Aid flow (current US$) in Maldives?
Provide a short and direct response. 2.10e+07. In the year 2005, what is the difference between the Aid flow (current US$) of Heavily indebted poor countries and Aid flow (current US$) of Nicaragua?
Ensure brevity in your answer.  2.18e+07. In the year 2005, what is the difference between the Aid flow (current US$) of Guyana and Aid flow (current US$) of Maldives?
Your answer should be very brief. -1.23e+06. In the year 2005, what is the difference between the Aid flow (current US$) of Guyana and Aid flow (current US$) of Nicaragua?
Offer a very short reply. -4.70e+05. In the year 2005, what is the difference between the Aid flow (current US$) of Maldives and Aid flow (current US$) of Nicaragua?
Ensure brevity in your answer.  7.60e+05. In the year 2006, what is the difference between the Aid flow (current US$) in Heavily indebted poor countries and Aid flow (current US$) in Guyana?
Give a very brief answer. 9.50e+06. In the year 2006, what is the difference between the Aid flow (current US$) in Heavily indebted poor countries and Aid flow (current US$) in Maldives?
Your response must be concise. 9.27e+06. In the year 2006, what is the difference between the Aid flow (current US$) of Heavily indebted poor countries and Aid flow (current US$) of Nicaragua?
Your answer should be very brief. 9.09e+06. In the year 2006, what is the difference between the Aid flow (current US$) of Guyana and Aid flow (current US$) of Nicaragua?
Keep it short and to the point. -4.10e+05. In the year 2007, what is the difference between the Aid flow (current US$) in Heavily indebted poor countries and Aid flow (current US$) in Guyana?
Your response must be concise. 1.05e+07. In the year 2007, what is the difference between the Aid flow (current US$) in Heavily indebted poor countries and Aid flow (current US$) in Maldives?
Provide a short and direct response. 1.01e+07. In the year 2007, what is the difference between the Aid flow (current US$) of Heavily indebted poor countries and Aid flow (current US$) of Nicaragua?
Ensure brevity in your answer.  9.89e+06. In the year 2007, what is the difference between the Aid flow (current US$) in Guyana and Aid flow (current US$) in Maldives?
Your response must be concise. -4.10e+05. In the year 2007, what is the difference between the Aid flow (current US$) of Guyana and Aid flow (current US$) of Nicaragua?
Provide a succinct answer. -6.40e+05. In the year 2008, what is the difference between the Aid flow (current US$) of Heavily indebted poor countries and Aid flow (current US$) of Guyana?
Provide a short and direct response. 1.56e+07. In the year 2008, what is the difference between the Aid flow (current US$) in Heavily indebted poor countries and Aid flow (current US$) in Maldives?
Provide a succinct answer. 1.51e+07. In the year 2008, what is the difference between the Aid flow (current US$) in Heavily indebted poor countries and Aid flow (current US$) in Nicaragua?
Provide a short and direct response. 1.53e+07. In the year 2008, what is the difference between the Aid flow (current US$) of Guyana and Aid flow (current US$) of Maldives?
Offer a terse response. -4.50e+05. In the year 2008, what is the difference between the Aid flow (current US$) of Guyana and Aid flow (current US$) of Nicaragua?
Provide a short and direct response. -2.70e+05. In the year 2008, what is the difference between the Aid flow (current US$) in Maldives and Aid flow (current US$) in Nicaragua?
Your response must be concise. 1.80e+05. In the year 2009, what is the difference between the Aid flow (current US$) in Heavily indebted poor countries and Aid flow (current US$) in Guyana?
Offer a very short reply. 9.92e+06. In the year 2009, what is the difference between the Aid flow (current US$) in Heavily indebted poor countries and Aid flow (current US$) in Maldives?
Your answer should be very brief. 9.48e+06. In the year 2009, what is the difference between the Aid flow (current US$) in Heavily indebted poor countries and Aid flow (current US$) in Nicaragua?
Keep it short and to the point. 9.58e+06. In the year 2009, what is the difference between the Aid flow (current US$) in Guyana and Aid flow (current US$) in Maldives?
Give a very brief answer. -4.40e+05. In the year 2009, what is the difference between the Aid flow (current US$) in Guyana and Aid flow (current US$) in Nicaragua?
Keep it short and to the point. -3.40e+05. In the year 2009, what is the difference between the Aid flow (current US$) of Maldives and Aid flow (current US$) of Nicaragua?
Your answer should be very brief. 1.00e+05. What is the ratio of the Aid flow (current US$) in Heavily indebted poor countries in 2000 to that in 2001?
Make the answer very short. 0.81. What is the ratio of the Aid flow (current US$) in Guyana in 2000 to that in 2001?
Provide a succinct answer. 1. What is the ratio of the Aid flow (current US$) in Maldives in 2000 to that in 2001?
Your answer should be compact. 2.25. What is the ratio of the Aid flow (current US$) of Heavily indebted poor countries in 2000 to that in 2002?
Provide a short and direct response. 0.48. What is the ratio of the Aid flow (current US$) of Guyana in 2000 to that in 2002?
Your response must be concise. 1. What is the ratio of the Aid flow (current US$) in Maldives in 2000 to that in 2002?
Your answer should be very brief. 0.93. What is the ratio of the Aid flow (current US$) of Nicaragua in 2000 to that in 2002?
Your answer should be very brief. 0.8. What is the ratio of the Aid flow (current US$) of Heavily indebted poor countries in 2000 to that in 2005?
Offer a very short reply. 0.14. What is the ratio of the Aid flow (current US$) in Guyana in 2000 to that in 2005?
Provide a short and direct response. 0.09. What is the ratio of the Aid flow (current US$) in Maldives in 2000 to that in 2005?
Offer a very short reply. 0.2. What is the ratio of the Aid flow (current US$) in Nicaragua in 2000 to that in 2005?
Provide a succinct answer. 0.14. What is the ratio of the Aid flow (current US$) of Heavily indebted poor countries in 2000 to that in 2006?
Provide a short and direct response. 0.32. What is the ratio of the Aid flow (current US$) in Maldives in 2000 to that in 2006?
Provide a short and direct response. 0.84. What is the ratio of the Aid flow (current US$) of Nicaragua in 2000 to that in 2006?
Your answer should be compact. 0.16. What is the ratio of the Aid flow (current US$) of Heavily indebted poor countries in 2000 to that in 2007?
Your response must be concise. 0.29. What is the ratio of the Aid flow (current US$) in Guyana in 2000 to that in 2007?
Your answer should be compact. 0.17. What is the ratio of the Aid flow (current US$) of Maldives in 2000 to that in 2007?
Your answer should be compact. 0.57. What is the ratio of the Aid flow (current US$) of Nicaragua in 2000 to that in 2007?
Provide a short and direct response. 0.11. What is the ratio of the Aid flow (current US$) in Heavily indebted poor countries in 2000 to that in 2008?
Your response must be concise. 0.2. What is the ratio of the Aid flow (current US$) in Maldives in 2000 to that in 2008?
Offer a very short reply. 0.54. What is the ratio of the Aid flow (current US$) in Heavily indebted poor countries in 2000 to that in 2009?
Provide a succinct answer. 0.31. What is the ratio of the Aid flow (current US$) of Guyana in 2000 to that in 2009?
Give a very brief answer. 0.17. What is the ratio of the Aid flow (current US$) in Maldives in 2000 to that in 2009?
Offer a very short reply. 0.54. What is the ratio of the Aid flow (current US$) in Nicaragua in 2000 to that in 2009?
Offer a very short reply. 0.2. What is the ratio of the Aid flow (current US$) in Heavily indebted poor countries in 2001 to that in 2002?
Your answer should be very brief. 0.59. What is the ratio of the Aid flow (current US$) in Guyana in 2001 to that in 2002?
Your response must be concise. 1. What is the ratio of the Aid flow (current US$) in Maldives in 2001 to that in 2002?
Keep it short and to the point. 0.41. What is the ratio of the Aid flow (current US$) of Nicaragua in 2001 to that in 2002?
Offer a terse response. 2. What is the ratio of the Aid flow (current US$) in Heavily indebted poor countries in 2001 to that in 2005?
Give a very brief answer. 0.17. What is the ratio of the Aid flow (current US$) in Guyana in 2001 to that in 2005?
Ensure brevity in your answer.  0.09. What is the ratio of the Aid flow (current US$) of Maldives in 2001 to that in 2005?
Make the answer very short. 0.09. What is the ratio of the Aid flow (current US$) in Nicaragua in 2001 to that in 2005?
Offer a very short reply. 0.34. What is the ratio of the Aid flow (current US$) of Heavily indebted poor countries in 2001 to that in 2006?
Offer a terse response. 0.4. What is the ratio of the Aid flow (current US$) in Heavily indebted poor countries in 2001 to that in 2007?
Offer a terse response. 0.36. What is the ratio of the Aid flow (current US$) in Guyana in 2001 to that in 2007?
Offer a very short reply. 0.17. What is the ratio of the Aid flow (current US$) of Maldives in 2001 to that in 2007?
Offer a terse response. 0.26. What is the ratio of the Aid flow (current US$) of Nicaragua in 2001 to that in 2007?
Provide a succinct answer. 0.29. What is the ratio of the Aid flow (current US$) of Heavily indebted poor countries in 2001 to that in 2008?
Provide a short and direct response. 0.24. What is the ratio of the Aid flow (current US$) in Maldives in 2001 to that in 2008?
Provide a short and direct response. 0.24. What is the ratio of the Aid flow (current US$) in Nicaragua in 2001 to that in 2008?
Make the answer very short. 0.62. What is the ratio of the Aid flow (current US$) of Heavily indebted poor countries in 2001 to that in 2009?
Your response must be concise. 0.38. What is the ratio of the Aid flow (current US$) of Guyana in 2001 to that in 2009?
Offer a terse response. 0.17. What is the ratio of the Aid flow (current US$) in Maldives in 2001 to that in 2009?
Make the answer very short. 0.24. What is the ratio of the Aid flow (current US$) of Nicaragua in 2001 to that in 2009?
Ensure brevity in your answer.  0.5. What is the ratio of the Aid flow (current US$) of Heavily indebted poor countries in 2002 to that in 2005?
Your answer should be very brief. 0.29. What is the ratio of the Aid flow (current US$) of Guyana in 2002 to that in 2005?
Your answer should be compact. 0.09. What is the ratio of the Aid flow (current US$) in Maldives in 2002 to that in 2005?
Provide a succinct answer. 0.22. What is the ratio of the Aid flow (current US$) of Nicaragua in 2002 to that in 2005?
Your answer should be very brief. 0.17. What is the ratio of the Aid flow (current US$) of Heavily indebted poor countries in 2002 to that in 2006?
Give a very brief answer. 0.67. What is the ratio of the Aid flow (current US$) of Guyana in 2002 to that in 2006?
Offer a terse response. 0.11. What is the ratio of the Aid flow (current US$) of Maldives in 2002 to that in 2006?
Offer a very short reply. 0.91. What is the ratio of the Aid flow (current US$) in Nicaragua in 2002 to that in 2006?
Make the answer very short. 0.2. What is the ratio of the Aid flow (current US$) of Heavily indebted poor countries in 2002 to that in 2007?
Your response must be concise. 0.61. What is the ratio of the Aid flow (current US$) in Maldives in 2002 to that in 2007?
Provide a succinct answer. 0.62. What is the ratio of the Aid flow (current US$) in Nicaragua in 2002 to that in 2007?
Offer a terse response. 0.14. What is the ratio of the Aid flow (current US$) of Heavily indebted poor countries in 2002 to that in 2008?
Keep it short and to the point. 0.41. What is the ratio of the Aid flow (current US$) in Guyana in 2002 to that in 2008?
Your answer should be very brief. 0.2. What is the ratio of the Aid flow (current US$) in Maldives in 2002 to that in 2008?
Your response must be concise. 0.58. What is the ratio of the Aid flow (current US$) of Nicaragua in 2002 to that in 2008?
Offer a terse response. 0.31. What is the ratio of the Aid flow (current US$) in Heavily indebted poor countries in 2002 to that in 2009?
Provide a short and direct response. 0.64. What is the ratio of the Aid flow (current US$) of Guyana in 2002 to that in 2009?
Provide a succinct answer. 0.17. What is the ratio of the Aid flow (current US$) in Maldives in 2002 to that in 2009?
Make the answer very short. 0.58. What is the ratio of the Aid flow (current US$) in Heavily indebted poor countries in 2005 to that in 2006?
Ensure brevity in your answer.  2.33. What is the ratio of the Aid flow (current US$) of Guyana in 2005 to that in 2006?
Your answer should be very brief. 1.22. What is the ratio of the Aid flow (current US$) of Maldives in 2005 to that in 2006?
Your answer should be compact. 4.19. What is the ratio of the Aid flow (current US$) in Nicaragua in 2005 to that in 2006?
Offer a terse response. 1.16. What is the ratio of the Aid flow (current US$) of Heavily indebted poor countries in 2005 to that in 2007?
Provide a short and direct response. 2.11. What is the ratio of the Aid flow (current US$) in Guyana in 2005 to that in 2007?
Keep it short and to the point. 1.83. What is the ratio of the Aid flow (current US$) in Maldives in 2005 to that in 2007?
Give a very brief answer. 2.85. What is the ratio of the Aid flow (current US$) in Nicaragua in 2005 to that in 2007?
Your answer should be compact. 0.83. What is the ratio of the Aid flow (current US$) in Heavily indebted poor countries in 2005 to that in 2008?
Ensure brevity in your answer.  1.43. What is the ratio of the Aid flow (current US$) of Guyana in 2005 to that in 2008?
Keep it short and to the point. 2.2. What is the ratio of the Aid flow (current US$) of Maldives in 2005 to that in 2008?
Provide a short and direct response. 2.68. What is the ratio of the Aid flow (current US$) in Nicaragua in 2005 to that in 2008?
Make the answer very short. 1.81. What is the ratio of the Aid flow (current US$) in Heavily indebted poor countries in 2005 to that in 2009?
Provide a succinct answer. 2.24. What is the ratio of the Aid flow (current US$) in Guyana in 2005 to that in 2009?
Provide a succinct answer. 1.83. What is the ratio of the Aid flow (current US$) in Maldives in 2005 to that in 2009?
Offer a very short reply. 2.68. What is the ratio of the Aid flow (current US$) of Nicaragua in 2005 to that in 2009?
Offer a terse response. 1.45. What is the ratio of the Aid flow (current US$) in Heavily indebted poor countries in 2006 to that in 2007?
Your answer should be very brief. 0.91. What is the ratio of the Aid flow (current US$) of Guyana in 2006 to that in 2007?
Give a very brief answer. 1.5. What is the ratio of the Aid flow (current US$) of Maldives in 2006 to that in 2007?
Make the answer very short. 0.68. What is the ratio of the Aid flow (current US$) of Nicaragua in 2006 to that in 2007?
Provide a succinct answer. 0.71. What is the ratio of the Aid flow (current US$) of Heavily indebted poor countries in 2006 to that in 2008?
Offer a terse response. 0.61. What is the ratio of the Aid flow (current US$) of Guyana in 2006 to that in 2008?
Your answer should be compact. 1.8. What is the ratio of the Aid flow (current US$) of Maldives in 2006 to that in 2008?
Your answer should be very brief. 0.64. What is the ratio of the Aid flow (current US$) in Nicaragua in 2006 to that in 2008?
Provide a short and direct response. 1.56. What is the ratio of the Aid flow (current US$) of Heavily indebted poor countries in 2006 to that in 2009?
Keep it short and to the point. 0.96. What is the ratio of the Aid flow (current US$) in Guyana in 2006 to that in 2009?
Your answer should be very brief. 1.5. What is the ratio of the Aid flow (current US$) in Maldives in 2006 to that in 2009?
Make the answer very short. 0.64. What is the ratio of the Aid flow (current US$) of Heavily indebted poor countries in 2007 to that in 2008?
Make the answer very short. 0.68. What is the ratio of the Aid flow (current US$) of Maldives in 2007 to that in 2008?
Your response must be concise. 0.94. What is the ratio of the Aid flow (current US$) of Nicaragua in 2007 to that in 2008?
Make the answer very short. 2.19. What is the ratio of the Aid flow (current US$) of Heavily indebted poor countries in 2007 to that in 2009?
Your answer should be compact. 1.06. What is the ratio of the Aid flow (current US$) of Guyana in 2007 to that in 2009?
Provide a succinct answer. 1. What is the ratio of the Aid flow (current US$) in Maldives in 2007 to that in 2009?
Make the answer very short. 0.94. What is the ratio of the Aid flow (current US$) in Nicaragua in 2007 to that in 2009?
Your answer should be very brief. 1.75. What is the ratio of the Aid flow (current US$) of Heavily indebted poor countries in 2008 to that in 2009?
Offer a very short reply. 1.56. What is the ratio of the Aid flow (current US$) of Maldives in 2008 to that in 2009?
Ensure brevity in your answer.  1. What is the ratio of the Aid flow (current US$) in Nicaragua in 2008 to that in 2009?
Your answer should be compact. 0.8. What is the difference between the highest and the second highest Aid flow (current US$) in Heavily indebted poor countries?
Make the answer very short. 6.73e+06. What is the difference between the highest and the second highest Aid flow (current US$) in Guyana?
Your answer should be compact. 2.00e+04. What is the difference between the highest and the second highest Aid flow (current US$) in Maldives?
Make the answer very short. 8.40e+05. What is the difference between the highest and the lowest Aid flow (current US$) of Heavily indebted poor countries?
Provide a succinct answer. 1.92e+07. What is the difference between the highest and the lowest Aid flow (current US$) of Maldives?
Make the answer very short. 1.22e+06. What is the difference between the highest and the lowest Aid flow (current US$) in Nicaragua?
Your answer should be very brief. 6.20e+05. 